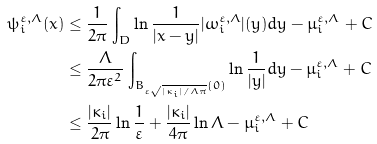Convert formula to latex. <formula><loc_0><loc_0><loc_500><loc_500>\psi ^ { \varepsilon , \Lambda } _ { i } ( x ) & \leq \frac { 1 } { 2 \pi } \int _ { D } \ln \frac { 1 } { | x - y | } | \omega ^ { \varepsilon , \Lambda } _ { i } | ( y ) d y - \mu ^ { \varepsilon , \Lambda } _ { i } + C \\ & \leq \frac { \Lambda } { 2 \pi \varepsilon ^ { 2 } } \int _ { B _ { { \varepsilon \sqrt { | \kappa _ { i } | / { \Lambda \pi } } } } ( 0 ) } \ln \frac { 1 } { | y | } d y - \mu ^ { \varepsilon , \Lambda } _ { i } + C \\ & \leq \frac { | \kappa _ { i } | } { 2 \pi } \ln \frac { 1 } { \varepsilon } + \frac { | \kappa _ { i } | } { 4 \pi } \ln \Lambda - \mu ^ { \varepsilon , \Lambda } _ { i } + C \\</formula> 